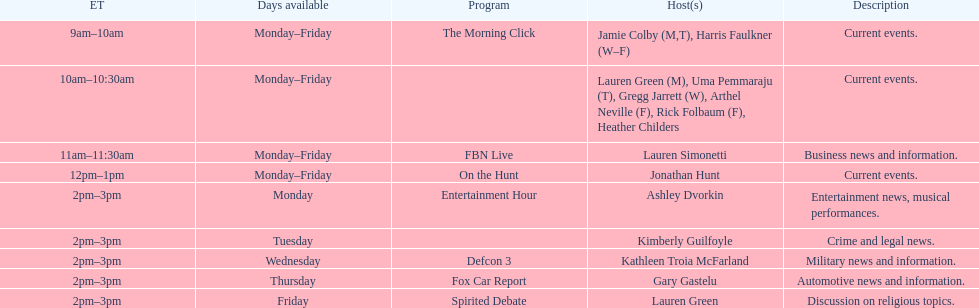How many days during the week does the show fbn live air? 5. 